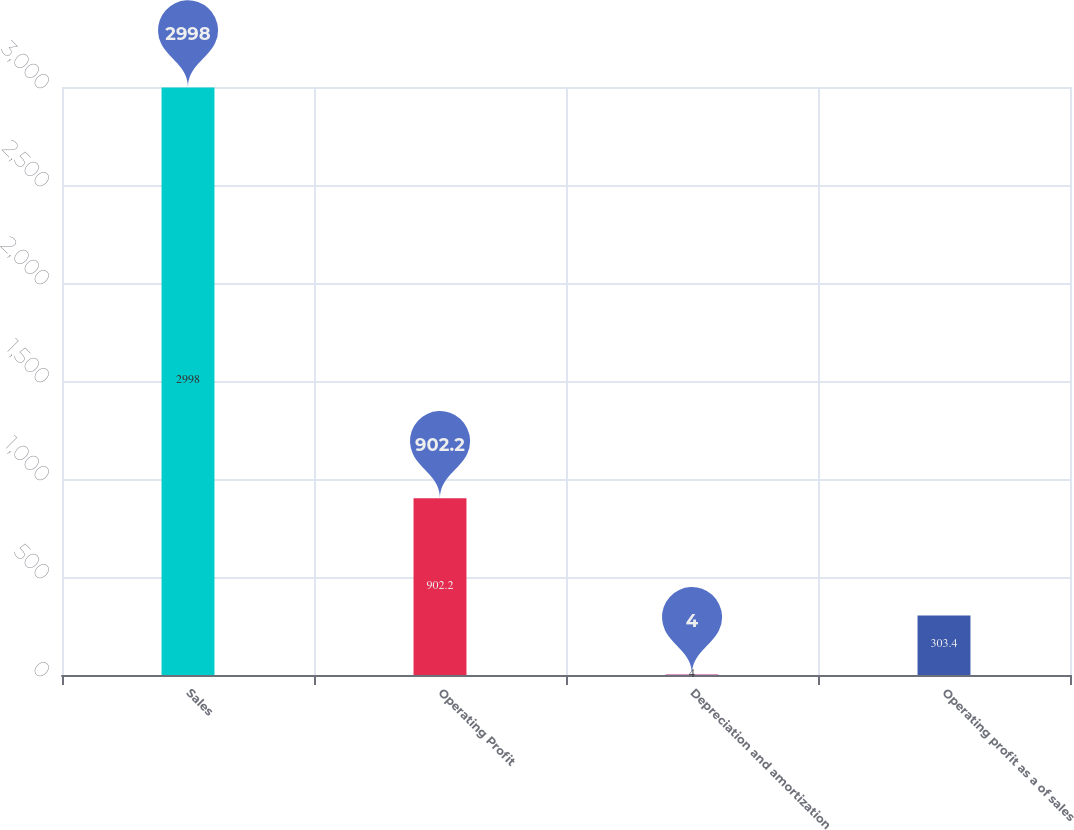<chart> <loc_0><loc_0><loc_500><loc_500><bar_chart><fcel>Sales<fcel>Operating Profit<fcel>Depreciation and amortization<fcel>Operating profit as a of sales<nl><fcel>2998<fcel>902.2<fcel>4<fcel>303.4<nl></chart> 